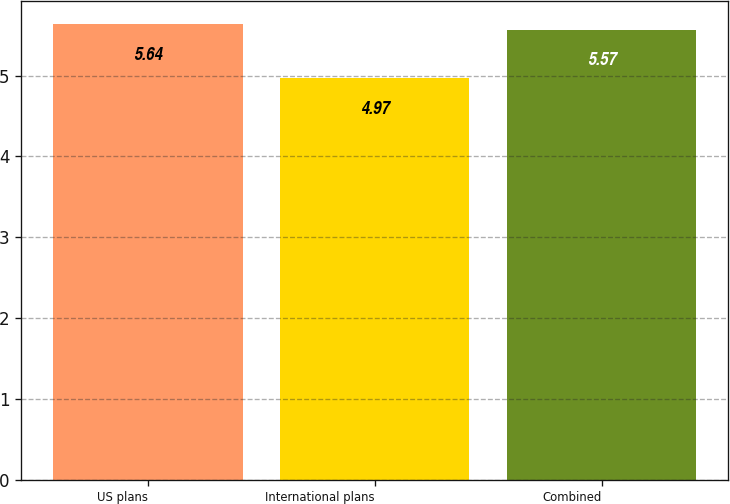<chart> <loc_0><loc_0><loc_500><loc_500><bar_chart><fcel>US plans<fcel>International plans<fcel>Combined<nl><fcel>5.64<fcel>4.97<fcel>5.57<nl></chart> 